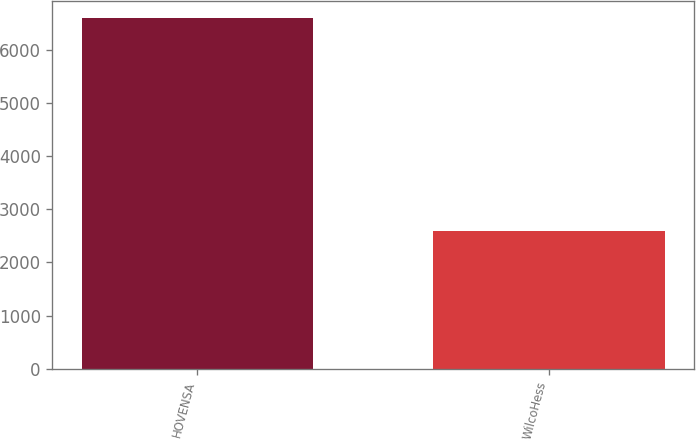Convert chart. <chart><loc_0><loc_0><loc_500><loc_500><bar_chart><fcel>HOVENSA<fcel>WilcoHess<nl><fcel>6589<fcel>2590<nl></chart> 